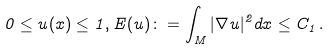Convert formula to latex. <formula><loc_0><loc_0><loc_500><loc_500>0 \leq u ( x ) \leq 1 , E ( u ) \colon = \int _ { M } | \nabla u | ^ { 2 } d x \leq C _ { 1 } \, .</formula> 